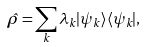Convert formula to latex. <formula><loc_0><loc_0><loc_500><loc_500>\hat { \rho } = \sum _ { k } \lambda _ { k } | \psi _ { k } \rangle \langle \psi _ { k } | ,</formula> 